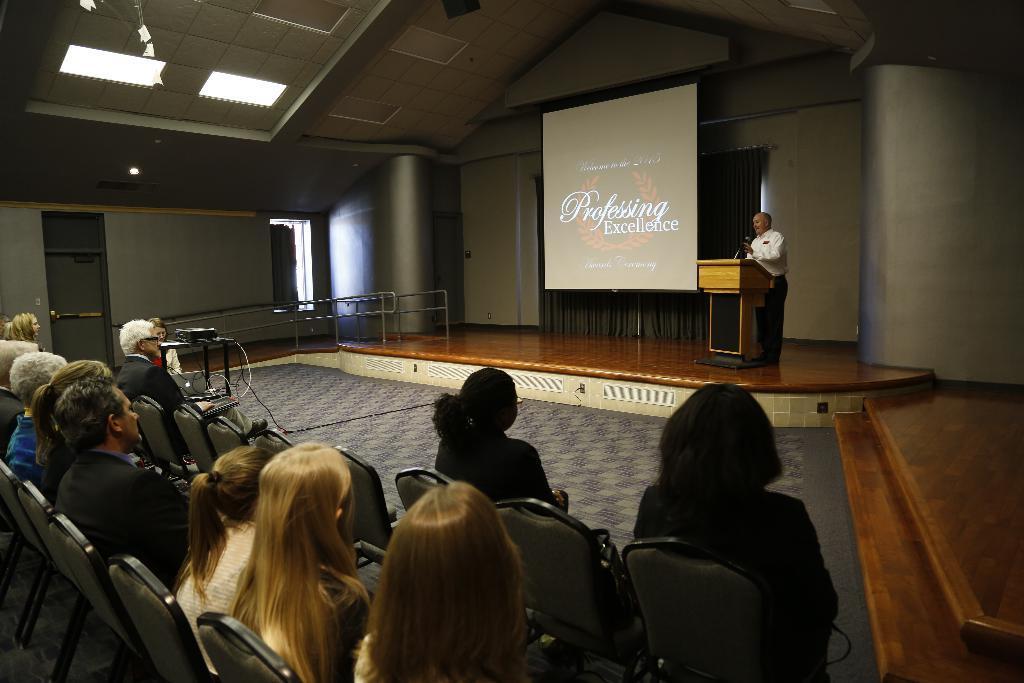Can you describe this image briefly? On the right side of the image we can see a man standing, before him there is a podium and a mic. In the center there is a screen and we can see a curtain. At the bottom there are people sitting and we can see a projector placed on the stand. At the top there are lights. In the background we can see a window and a door. 